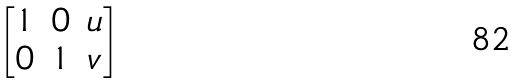Convert formula to latex. <formula><loc_0><loc_0><loc_500><loc_500>\begin{bmatrix} 1 & 0 & u \\ 0 & 1 & v \end{bmatrix}</formula> 